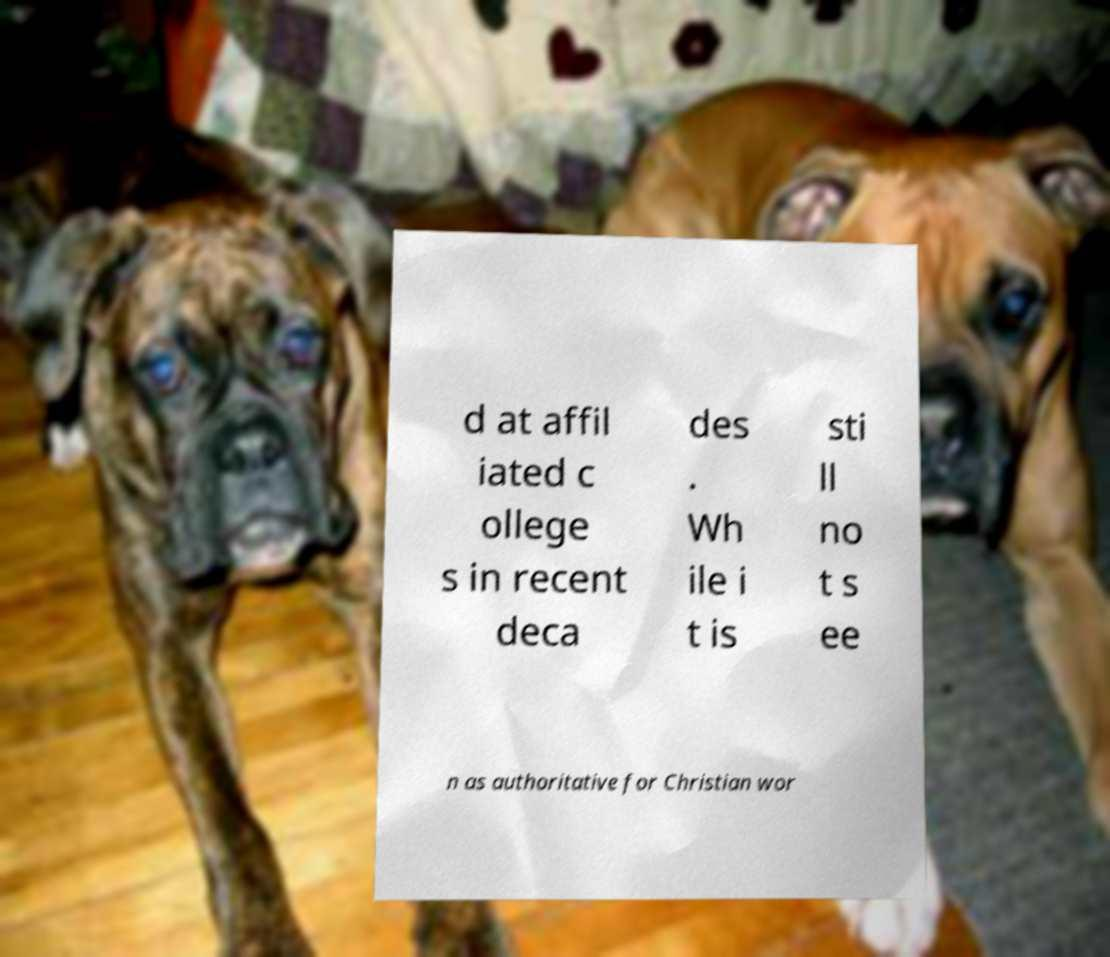For documentation purposes, I need the text within this image transcribed. Could you provide that? d at affil iated c ollege s in recent deca des . Wh ile i t is sti ll no t s ee n as authoritative for Christian wor 